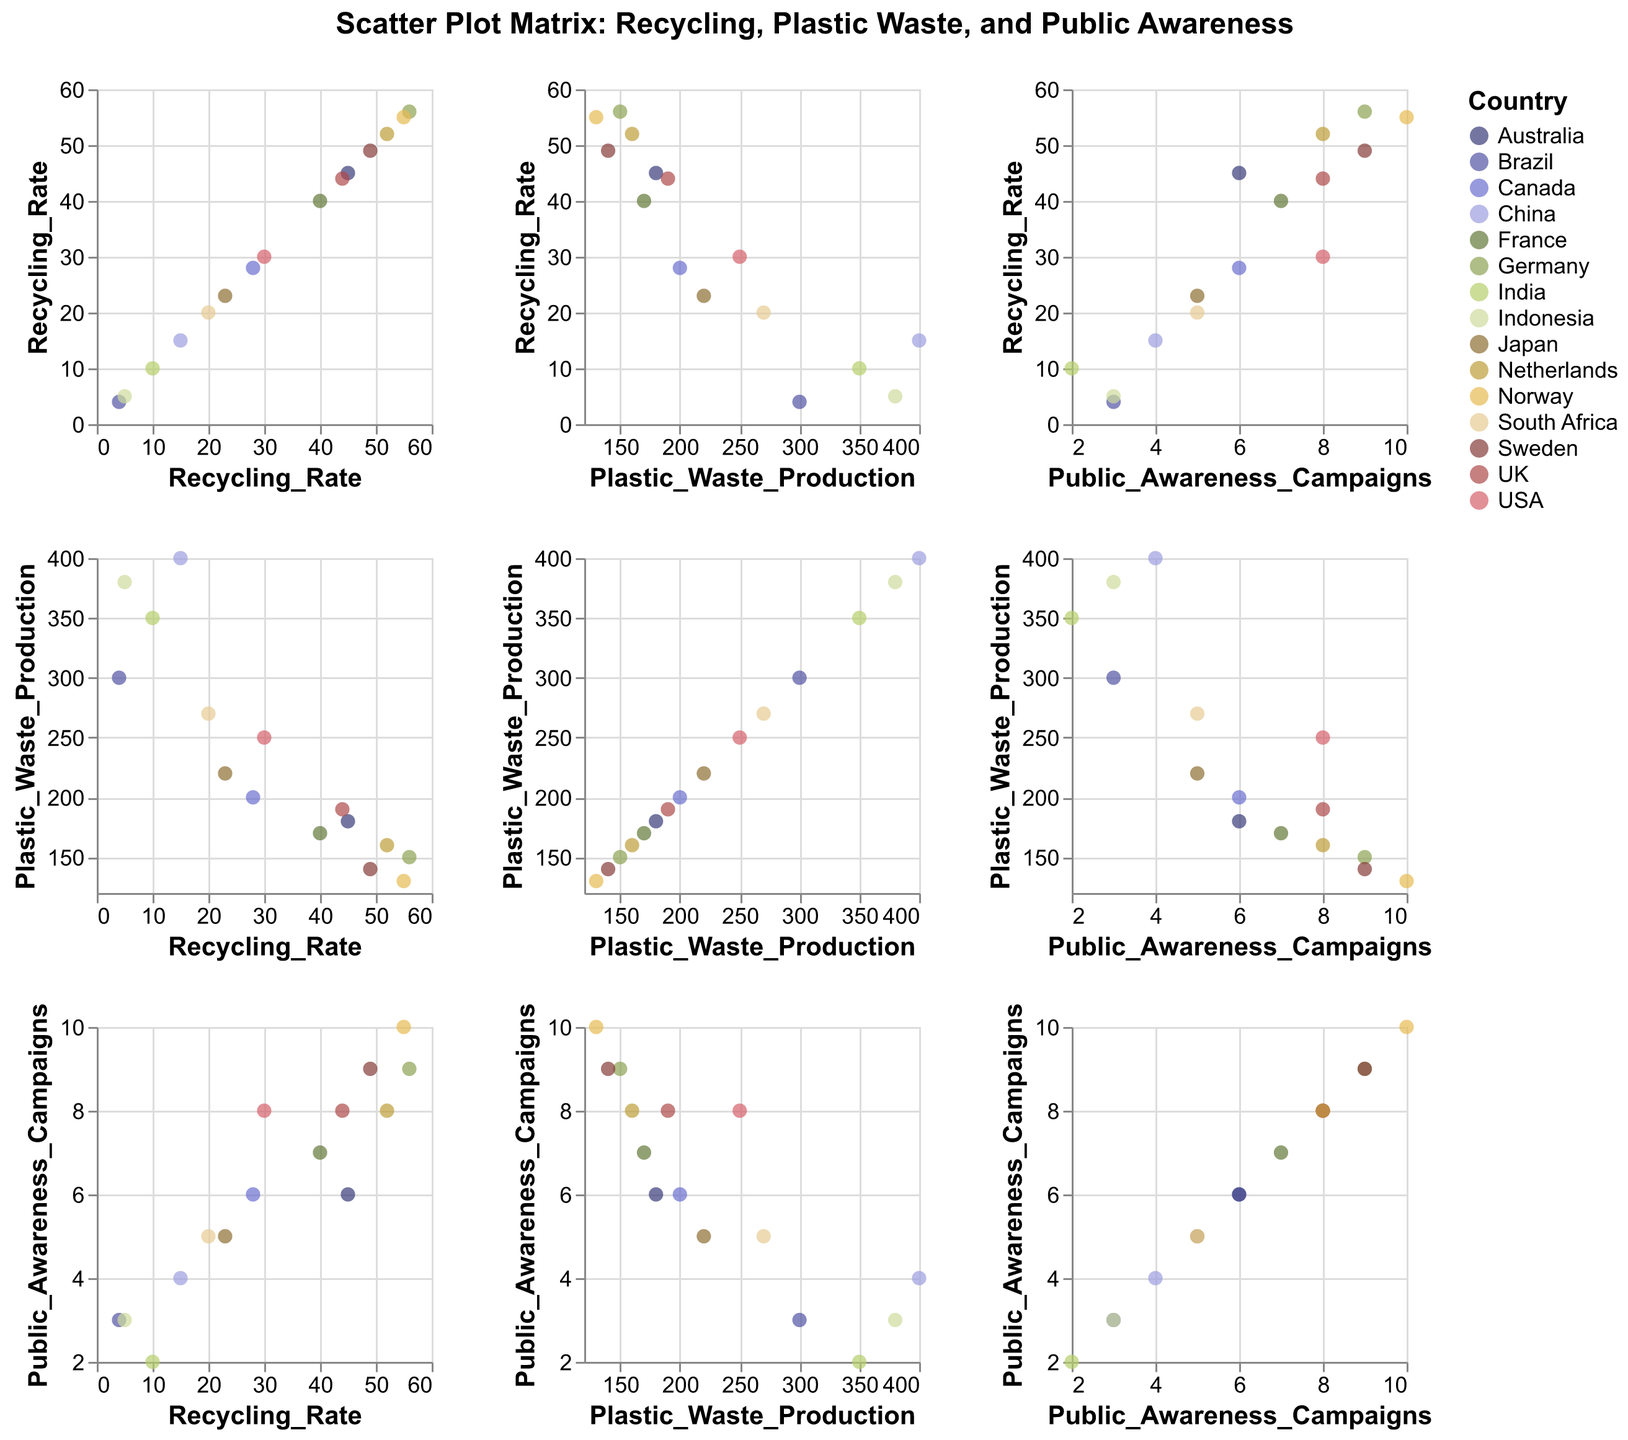What country has the highest recycling rate? By looking at the Recycling Rate axis, we can see that Germany has the highest value at 56%.
Answer: Germany Which country produces the most plastic waste? By examining the Plastic Waste Production axis, we identify that China has the highest value at 400.
Answer: China How many public awareness campaigns does Norway have? For the country Norway, the data point on the Public Awareness Campaigns axis is at the value 10.
Answer: 10 What's the average recycling rate for the top three countries with the highest recycling rates? The top three countries are Germany (56), Norway (55), and Netherlands (52). The average is (56 + 55 + 52) / 3 = 54.33.
Answer: 54.33 Is there a country that has a recycling rate over 50% and public awareness campaigns over 8? By looking at both Recycling Rate and Public Awareness Campaigns, Germany (56%, 9), and Norway (55%, 10) meet these criteria.
Answer: Germany, Norway Does higher public awareness correlate with higher recycling rates? High public awareness tends to overlap with higher recycling rates, as seen with Germany, Sweden, and Norway having both high recycling rates and public awareness campaigns.
Answer: Yes, generally Which country has the greatest difference between recycling rate and plastic waste produced? Subtract the Plastic Waste Production from Recycling Rate for each country, the greatest difference is in China (400 - 15 = 385).
Answer: China Is there a visible trend between recycling rate and plastic waste production? Generally, countries with higher recycling rates tend to produce less plastic waste, indicating an inverse relationship.
Answer: Yes, inverse relationship How many countries have less than 10 public awareness campaigns? Count the countries with Public Awareness Campaigns value below 10: USA, Canada, France, Japan, Australia, UK, Brazil, India, China, South Africa, Indonesia (11 countries).
Answer: 11 Which country has the lowest recycling rate and how many public awareness campaigns do they have? Brazil has the lowest recycling rate at 4% and has 3 public awareness campaigns.
Answer: Brazil, 3 